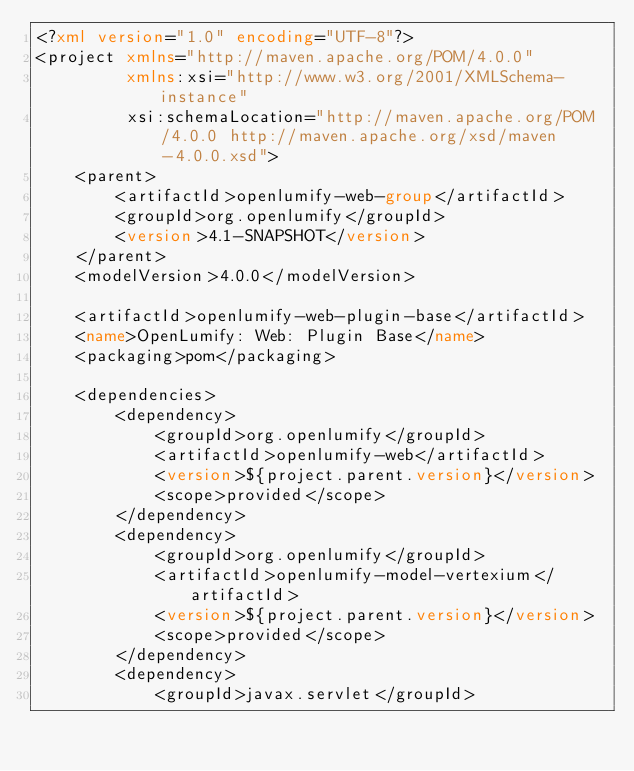Convert code to text. <code><loc_0><loc_0><loc_500><loc_500><_XML_><?xml version="1.0" encoding="UTF-8"?>
<project xmlns="http://maven.apache.org/POM/4.0.0"
         xmlns:xsi="http://www.w3.org/2001/XMLSchema-instance"
         xsi:schemaLocation="http://maven.apache.org/POM/4.0.0 http://maven.apache.org/xsd/maven-4.0.0.xsd">
    <parent>
        <artifactId>openlumify-web-group</artifactId>
        <groupId>org.openlumify</groupId>
        <version>4.1-SNAPSHOT</version>
    </parent>
    <modelVersion>4.0.0</modelVersion>

    <artifactId>openlumify-web-plugin-base</artifactId>
    <name>OpenLumify: Web: Plugin Base</name>
    <packaging>pom</packaging>

    <dependencies>
        <dependency>
            <groupId>org.openlumify</groupId>
            <artifactId>openlumify-web</artifactId>
            <version>${project.parent.version}</version>
            <scope>provided</scope>
        </dependency>
        <dependency>
            <groupId>org.openlumify</groupId>
            <artifactId>openlumify-model-vertexium</artifactId>
            <version>${project.parent.version}</version>
            <scope>provided</scope>
        </dependency>
        <dependency>
            <groupId>javax.servlet</groupId></code> 